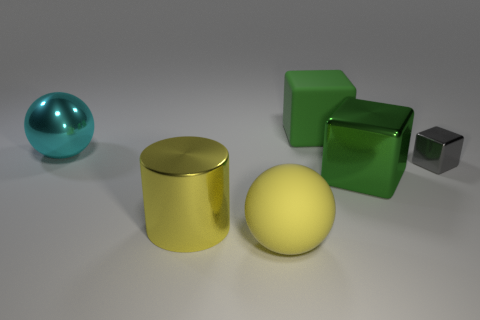There is a big green cube that is behind the large metallic object that is on the right side of the yellow matte object; how many large yellow cylinders are behind it?
Ensure brevity in your answer.  0. Are there any other things that are the same material as the small thing?
Your answer should be very brief. Yes. Is the number of tiny things that are in front of the matte ball less than the number of tiny blue matte spheres?
Make the answer very short. No. Does the big rubber cube have the same color as the matte sphere?
Provide a short and direct response. No. What size is the other object that is the same shape as the large yellow matte thing?
Offer a very short reply. Large. What number of large green blocks are the same material as the gray cube?
Your response must be concise. 1. Do the green block that is right of the large green rubber object and the large cyan ball have the same material?
Offer a terse response. Yes. Are there an equal number of yellow metallic things that are to the left of the large metallic cube and small brown metal balls?
Your answer should be compact. No. How big is the metallic cylinder?
Offer a very short reply. Large. There is another large cube that is the same color as the rubber cube; what is its material?
Offer a terse response. Metal. 